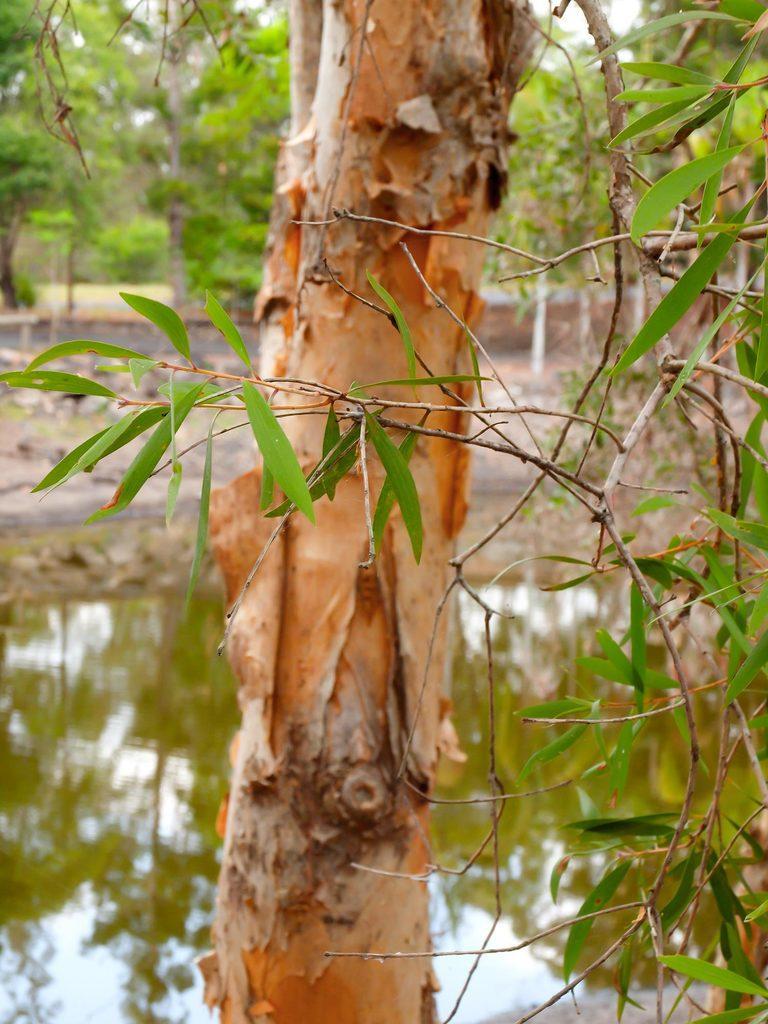How would you summarize this image in a sentence or two? In this picture I can see trees and I can see water. 